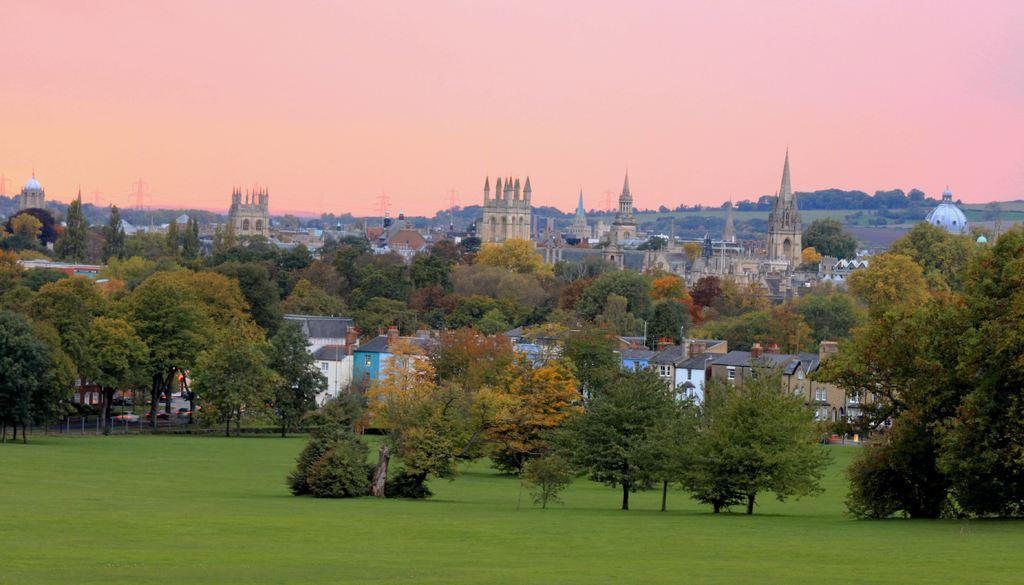What type of vegetation can be seen in the image? There are trees in the image. What type of structures are present in the image? There are buildings with windows in the image. What is the ground covered with in the image? There is grass in the image. What type of barrier is present in the image? There is a fence in the image. What can be seen in the background of the image? The sky is visible in the background of the image. What question is being asked by the kitten in the image? There is no kitten present in the image, so no question can be asked by a kitten. Who is the creator of the image? The creator of the image is not mentioned in the provided facts, so we cannot determine who created the image. 